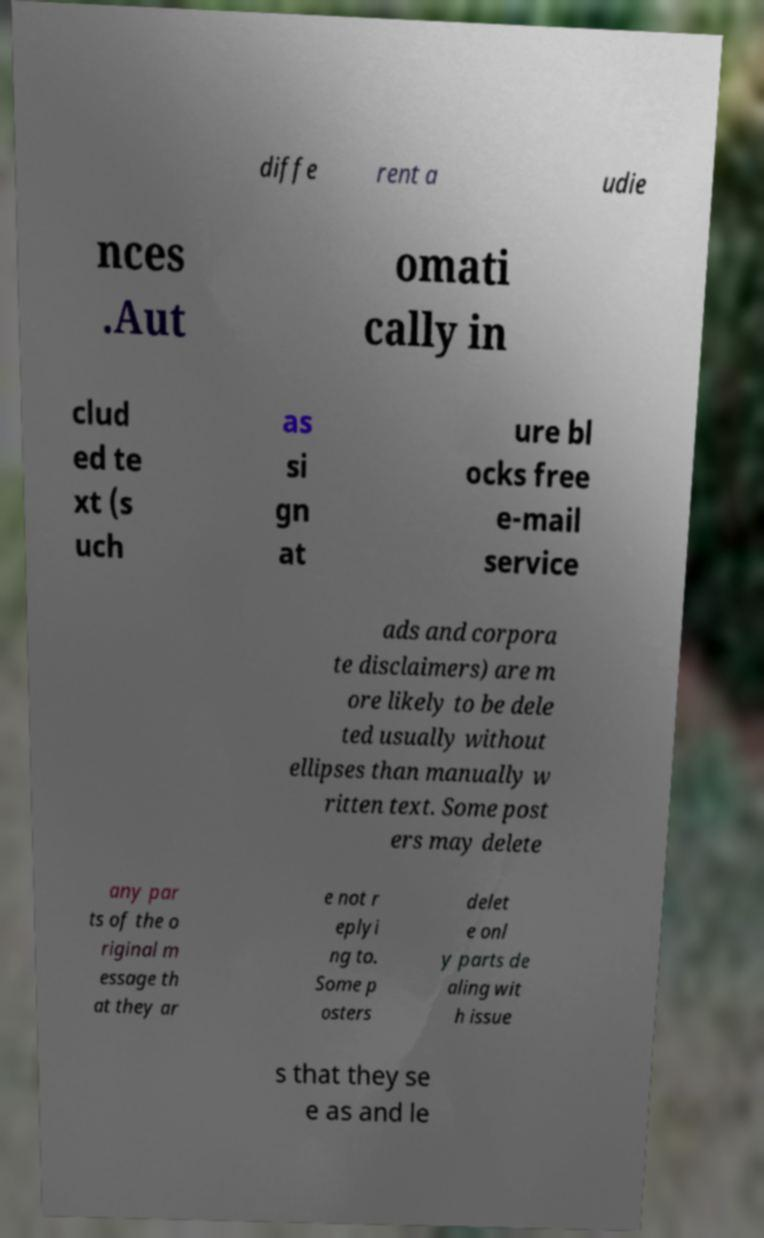Can you read and provide the text displayed in the image?This photo seems to have some interesting text. Can you extract and type it out for me? diffe rent a udie nces .Aut omati cally in clud ed te xt (s uch as si gn at ure bl ocks free e-mail service ads and corpora te disclaimers) are m ore likely to be dele ted usually without ellipses than manually w ritten text. Some post ers may delete any par ts of the o riginal m essage th at they ar e not r eplyi ng to. Some p osters delet e onl y parts de aling wit h issue s that they se e as and le 